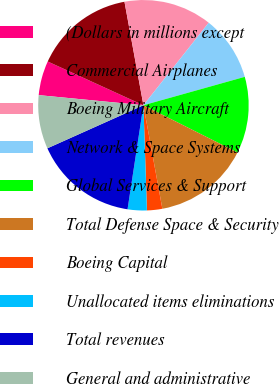Convert chart to OTSL. <chart><loc_0><loc_0><loc_500><loc_500><pie_chart><fcel>(Dollars in millions except<fcel>Commercial Airplanes<fcel>Boeing Military Aircraft<fcel>Network & Space Systems<fcel>Global Services & Support<fcel>Total Defense Space & Security<fcel>Boeing Capital<fcel>Unallocated items eliminations<fcel>Total revenues<fcel>General and administrative<nl><fcel>5.29%<fcel>15.29%<fcel>13.53%<fcel>10.0%<fcel>11.76%<fcel>14.71%<fcel>2.35%<fcel>2.94%<fcel>15.88%<fcel>8.24%<nl></chart> 